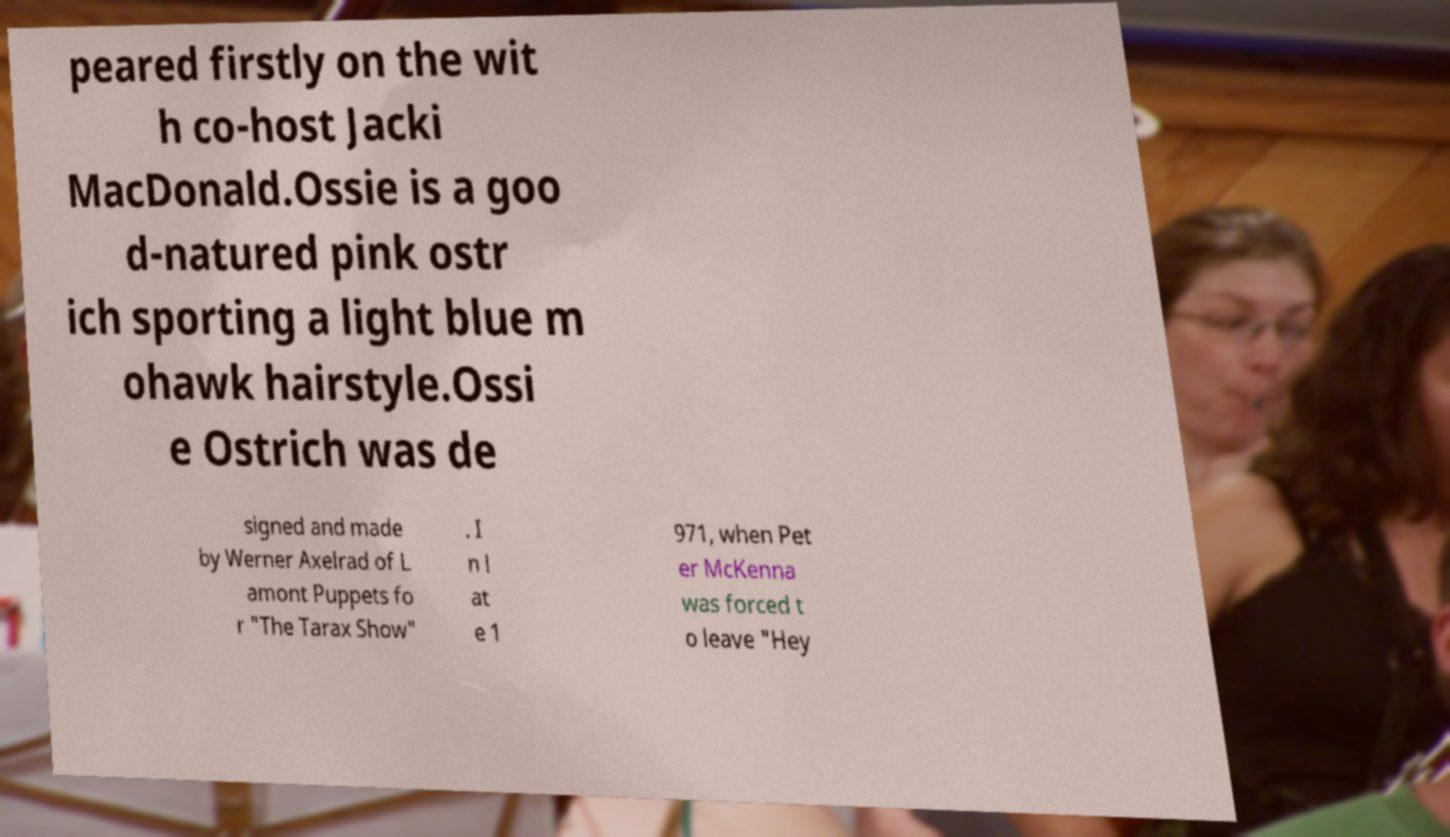Please identify and transcribe the text found in this image. peared firstly on the wit h co-host Jacki MacDonald.Ossie is a goo d-natured pink ostr ich sporting a light blue m ohawk hairstyle.Ossi e Ostrich was de signed and made by Werner Axelrad of L amont Puppets fo r "The Tarax Show" . I n l at e 1 971, when Pet er McKenna was forced t o leave "Hey 